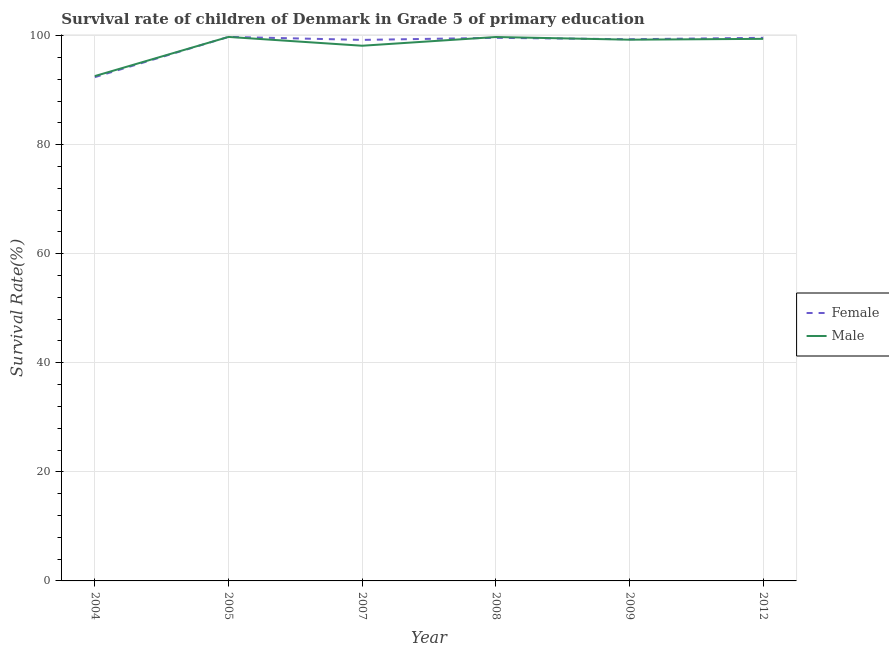What is the survival rate of female students in primary education in 2004?
Offer a terse response. 92.38. Across all years, what is the maximum survival rate of male students in primary education?
Give a very brief answer. 99.75. Across all years, what is the minimum survival rate of male students in primary education?
Provide a succinct answer. 92.57. What is the total survival rate of female students in primary education in the graph?
Make the answer very short. 589.84. What is the difference between the survival rate of female students in primary education in 2005 and that in 2012?
Give a very brief answer. 0.17. What is the difference between the survival rate of female students in primary education in 2009 and the survival rate of male students in primary education in 2007?
Your answer should be compact. 1.19. What is the average survival rate of male students in primary education per year?
Offer a very short reply. 98.14. In the year 2005, what is the difference between the survival rate of male students in primary education and survival rate of female students in primary education?
Provide a succinct answer. -0.01. What is the ratio of the survival rate of male students in primary education in 2004 to that in 2009?
Provide a succinct answer. 0.93. Is the difference between the survival rate of female students in primary education in 2004 and 2009 greater than the difference between the survival rate of male students in primary education in 2004 and 2009?
Keep it short and to the point. No. What is the difference between the highest and the second highest survival rate of male students in primary education?
Ensure brevity in your answer.  0.02. What is the difference between the highest and the lowest survival rate of male students in primary education?
Make the answer very short. 7.18. In how many years, is the survival rate of female students in primary education greater than the average survival rate of female students in primary education taken over all years?
Give a very brief answer. 5. How many lines are there?
Offer a terse response. 2. How many years are there in the graph?
Your answer should be compact. 6. What is the difference between two consecutive major ticks on the Y-axis?
Provide a short and direct response. 20. Are the values on the major ticks of Y-axis written in scientific E-notation?
Offer a very short reply. No. Does the graph contain grids?
Provide a succinct answer. Yes. Where does the legend appear in the graph?
Offer a terse response. Center right. How are the legend labels stacked?
Keep it short and to the point. Vertical. What is the title of the graph?
Make the answer very short. Survival rate of children of Denmark in Grade 5 of primary education. What is the label or title of the X-axis?
Provide a short and direct response. Year. What is the label or title of the Y-axis?
Your answer should be compact. Survival Rate(%). What is the Survival Rate(%) of Female in 2004?
Your answer should be compact. 92.38. What is the Survival Rate(%) in Male in 2004?
Offer a terse response. 92.57. What is the Survival Rate(%) of Female in 2005?
Ensure brevity in your answer.  99.76. What is the Survival Rate(%) in Male in 2005?
Keep it short and to the point. 99.75. What is the Survival Rate(%) of Female in 2007?
Make the answer very short. 99.2. What is the Survival Rate(%) in Male in 2007?
Provide a succinct answer. 98.13. What is the Survival Rate(%) of Female in 2008?
Ensure brevity in your answer.  99.59. What is the Survival Rate(%) of Male in 2008?
Ensure brevity in your answer.  99.73. What is the Survival Rate(%) of Female in 2009?
Offer a very short reply. 99.32. What is the Survival Rate(%) in Male in 2009?
Give a very brief answer. 99.24. What is the Survival Rate(%) in Female in 2012?
Provide a short and direct response. 99.59. What is the Survival Rate(%) of Male in 2012?
Your answer should be very brief. 99.4. Across all years, what is the maximum Survival Rate(%) of Female?
Provide a succinct answer. 99.76. Across all years, what is the maximum Survival Rate(%) of Male?
Your answer should be compact. 99.75. Across all years, what is the minimum Survival Rate(%) in Female?
Your response must be concise. 92.38. Across all years, what is the minimum Survival Rate(%) of Male?
Your answer should be very brief. 92.57. What is the total Survival Rate(%) of Female in the graph?
Ensure brevity in your answer.  589.84. What is the total Survival Rate(%) in Male in the graph?
Provide a short and direct response. 588.83. What is the difference between the Survival Rate(%) of Female in 2004 and that in 2005?
Keep it short and to the point. -7.38. What is the difference between the Survival Rate(%) of Male in 2004 and that in 2005?
Offer a very short reply. -7.18. What is the difference between the Survival Rate(%) of Female in 2004 and that in 2007?
Give a very brief answer. -6.83. What is the difference between the Survival Rate(%) in Male in 2004 and that in 2007?
Give a very brief answer. -5.56. What is the difference between the Survival Rate(%) of Female in 2004 and that in 2008?
Offer a terse response. -7.21. What is the difference between the Survival Rate(%) in Male in 2004 and that in 2008?
Ensure brevity in your answer.  -7.16. What is the difference between the Survival Rate(%) in Female in 2004 and that in 2009?
Your response must be concise. -6.95. What is the difference between the Survival Rate(%) in Male in 2004 and that in 2009?
Give a very brief answer. -6.67. What is the difference between the Survival Rate(%) in Female in 2004 and that in 2012?
Make the answer very short. -7.21. What is the difference between the Survival Rate(%) in Male in 2004 and that in 2012?
Provide a succinct answer. -6.83. What is the difference between the Survival Rate(%) of Female in 2005 and that in 2007?
Ensure brevity in your answer.  0.55. What is the difference between the Survival Rate(%) in Male in 2005 and that in 2007?
Your answer should be very brief. 1.62. What is the difference between the Survival Rate(%) in Female in 2005 and that in 2008?
Make the answer very short. 0.17. What is the difference between the Survival Rate(%) of Male in 2005 and that in 2008?
Keep it short and to the point. 0.02. What is the difference between the Survival Rate(%) of Female in 2005 and that in 2009?
Your answer should be compact. 0.43. What is the difference between the Survival Rate(%) in Male in 2005 and that in 2009?
Your response must be concise. 0.51. What is the difference between the Survival Rate(%) of Female in 2005 and that in 2012?
Provide a succinct answer. 0.17. What is the difference between the Survival Rate(%) in Male in 2005 and that in 2012?
Make the answer very short. 0.35. What is the difference between the Survival Rate(%) in Female in 2007 and that in 2008?
Give a very brief answer. -0.38. What is the difference between the Survival Rate(%) of Male in 2007 and that in 2008?
Your answer should be very brief. -1.6. What is the difference between the Survival Rate(%) in Female in 2007 and that in 2009?
Your answer should be very brief. -0.12. What is the difference between the Survival Rate(%) of Male in 2007 and that in 2009?
Keep it short and to the point. -1.11. What is the difference between the Survival Rate(%) in Female in 2007 and that in 2012?
Give a very brief answer. -0.38. What is the difference between the Survival Rate(%) in Male in 2007 and that in 2012?
Give a very brief answer. -1.26. What is the difference between the Survival Rate(%) of Female in 2008 and that in 2009?
Ensure brevity in your answer.  0.26. What is the difference between the Survival Rate(%) in Male in 2008 and that in 2009?
Your response must be concise. 0.49. What is the difference between the Survival Rate(%) of Female in 2008 and that in 2012?
Your answer should be very brief. -0. What is the difference between the Survival Rate(%) in Male in 2008 and that in 2012?
Provide a short and direct response. 0.33. What is the difference between the Survival Rate(%) in Female in 2009 and that in 2012?
Offer a terse response. -0.26. What is the difference between the Survival Rate(%) of Male in 2009 and that in 2012?
Keep it short and to the point. -0.16. What is the difference between the Survival Rate(%) of Female in 2004 and the Survival Rate(%) of Male in 2005?
Give a very brief answer. -7.38. What is the difference between the Survival Rate(%) in Female in 2004 and the Survival Rate(%) in Male in 2007?
Provide a succinct answer. -5.76. What is the difference between the Survival Rate(%) in Female in 2004 and the Survival Rate(%) in Male in 2008?
Keep it short and to the point. -7.36. What is the difference between the Survival Rate(%) in Female in 2004 and the Survival Rate(%) in Male in 2009?
Keep it short and to the point. -6.87. What is the difference between the Survival Rate(%) in Female in 2004 and the Survival Rate(%) in Male in 2012?
Give a very brief answer. -7.02. What is the difference between the Survival Rate(%) of Female in 2005 and the Survival Rate(%) of Male in 2007?
Offer a terse response. 1.62. What is the difference between the Survival Rate(%) of Female in 2005 and the Survival Rate(%) of Male in 2008?
Ensure brevity in your answer.  0.02. What is the difference between the Survival Rate(%) of Female in 2005 and the Survival Rate(%) of Male in 2009?
Your response must be concise. 0.51. What is the difference between the Survival Rate(%) in Female in 2005 and the Survival Rate(%) in Male in 2012?
Your answer should be very brief. 0.36. What is the difference between the Survival Rate(%) in Female in 2007 and the Survival Rate(%) in Male in 2008?
Make the answer very short. -0.53. What is the difference between the Survival Rate(%) in Female in 2007 and the Survival Rate(%) in Male in 2009?
Your response must be concise. -0.04. What is the difference between the Survival Rate(%) in Female in 2007 and the Survival Rate(%) in Male in 2012?
Offer a terse response. -0.19. What is the difference between the Survival Rate(%) in Female in 2008 and the Survival Rate(%) in Male in 2009?
Your answer should be very brief. 0.34. What is the difference between the Survival Rate(%) in Female in 2008 and the Survival Rate(%) in Male in 2012?
Your answer should be very brief. 0.19. What is the difference between the Survival Rate(%) in Female in 2009 and the Survival Rate(%) in Male in 2012?
Your answer should be compact. -0.07. What is the average Survival Rate(%) in Female per year?
Keep it short and to the point. 98.31. What is the average Survival Rate(%) in Male per year?
Make the answer very short. 98.14. In the year 2004, what is the difference between the Survival Rate(%) of Female and Survival Rate(%) of Male?
Keep it short and to the point. -0.19. In the year 2005, what is the difference between the Survival Rate(%) of Female and Survival Rate(%) of Male?
Your answer should be very brief. 0.01. In the year 2007, what is the difference between the Survival Rate(%) of Female and Survival Rate(%) of Male?
Make the answer very short. 1.07. In the year 2008, what is the difference between the Survival Rate(%) in Female and Survival Rate(%) in Male?
Offer a very short reply. -0.15. In the year 2009, what is the difference between the Survival Rate(%) of Female and Survival Rate(%) of Male?
Give a very brief answer. 0.08. In the year 2012, what is the difference between the Survival Rate(%) of Female and Survival Rate(%) of Male?
Your response must be concise. 0.19. What is the ratio of the Survival Rate(%) of Female in 2004 to that in 2005?
Make the answer very short. 0.93. What is the ratio of the Survival Rate(%) in Male in 2004 to that in 2005?
Your response must be concise. 0.93. What is the ratio of the Survival Rate(%) in Female in 2004 to that in 2007?
Your answer should be compact. 0.93. What is the ratio of the Survival Rate(%) in Male in 2004 to that in 2007?
Give a very brief answer. 0.94. What is the ratio of the Survival Rate(%) in Female in 2004 to that in 2008?
Make the answer very short. 0.93. What is the ratio of the Survival Rate(%) in Male in 2004 to that in 2008?
Your answer should be compact. 0.93. What is the ratio of the Survival Rate(%) of Male in 2004 to that in 2009?
Ensure brevity in your answer.  0.93. What is the ratio of the Survival Rate(%) in Female in 2004 to that in 2012?
Ensure brevity in your answer.  0.93. What is the ratio of the Survival Rate(%) of Male in 2004 to that in 2012?
Give a very brief answer. 0.93. What is the ratio of the Survival Rate(%) of Female in 2005 to that in 2007?
Provide a short and direct response. 1.01. What is the ratio of the Survival Rate(%) in Male in 2005 to that in 2007?
Ensure brevity in your answer.  1.02. What is the ratio of the Survival Rate(%) of Female in 2005 to that in 2008?
Ensure brevity in your answer.  1. What is the ratio of the Survival Rate(%) in Male in 2005 to that in 2008?
Provide a short and direct response. 1. What is the ratio of the Survival Rate(%) of Female in 2005 to that in 2009?
Your answer should be compact. 1. What is the ratio of the Survival Rate(%) of Female in 2007 to that in 2008?
Ensure brevity in your answer.  1. What is the ratio of the Survival Rate(%) of Female in 2007 to that in 2012?
Keep it short and to the point. 1. What is the ratio of the Survival Rate(%) in Male in 2007 to that in 2012?
Your answer should be compact. 0.99. What is the ratio of the Survival Rate(%) of Female in 2008 to that in 2012?
Keep it short and to the point. 1. What is the ratio of the Survival Rate(%) of Female in 2009 to that in 2012?
Provide a short and direct response. 1. What is the ratio of the Survival Rate(%) of Male in 2009 to that in 2012?
Ensure brevity in your answer.  1. What is the difference between the highest and the second highest Survival Rate(%) in Female?
Provide a short and direct response. 0.17. What is the difference between the highest and the second highest Survival Rate(%) in Male?
Offer a very short reply. 0.02. What is the difference between the highest and the lowest Survival Rate(%) of Female?
Your answer should be very brief. 7.38. What is the difference between the highest and the lowest Survival Rate(%) of Male?
Your answer should be very brief. 7.18. 